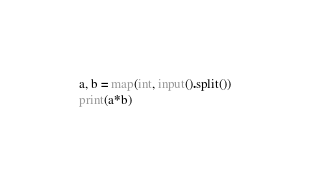<code> <loc_0><loc_0><loc_500><loc_500><_Python_>a, b = map(int, input().split())
print(a*b)</code> 